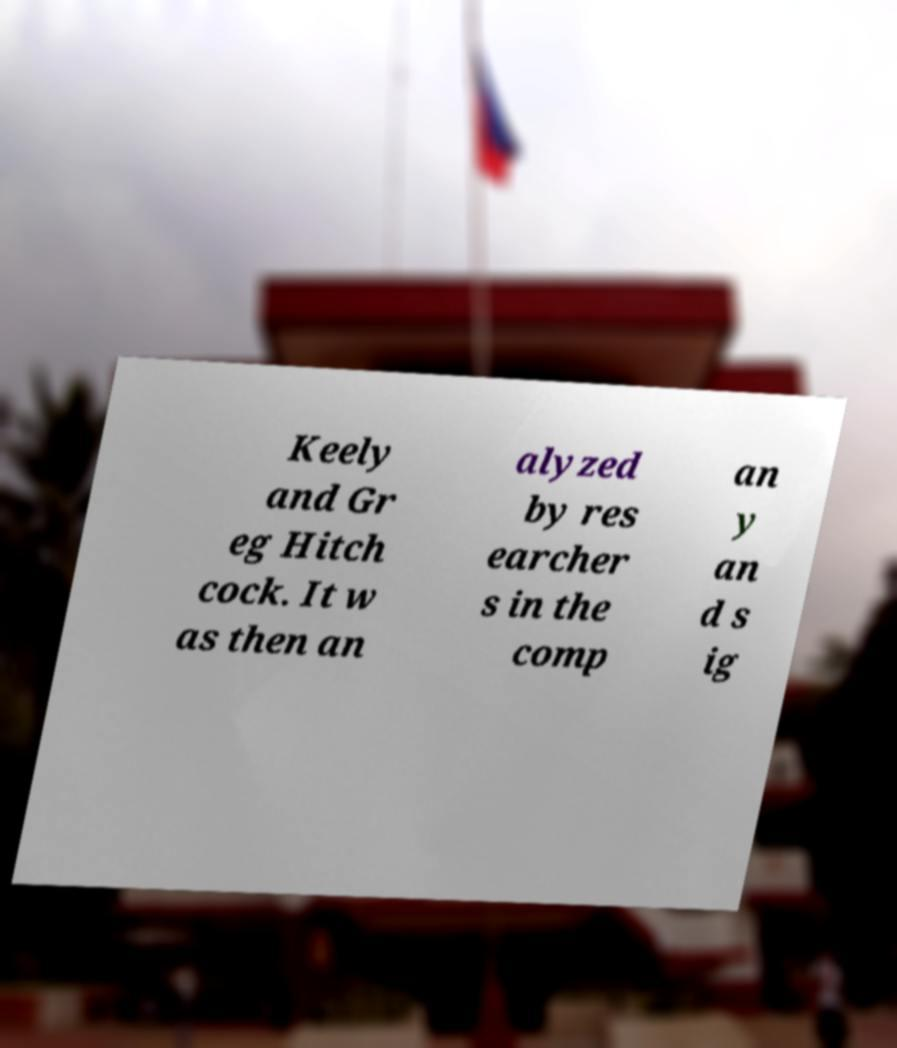Please identify and transcribe the text found in this image. Keely and Gr eg Hitch cock. It w as then an alyzed by res earcher s in the comp an y an d s ig 